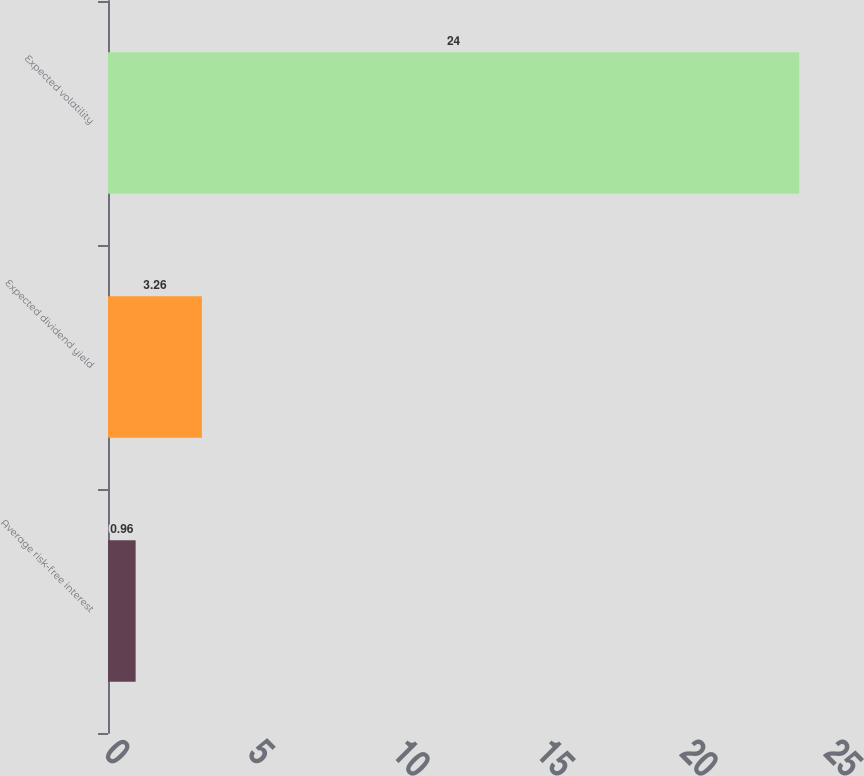<chart> <loc_0><loc_0><loc_500><loc_500><bar_chart><fcel>Average risk-free interest<fcel>Expected dividend yield<fcel>Expected volatility<nl><fcel>0.96<fcel>3.26<fcel>24<nl></chart> 